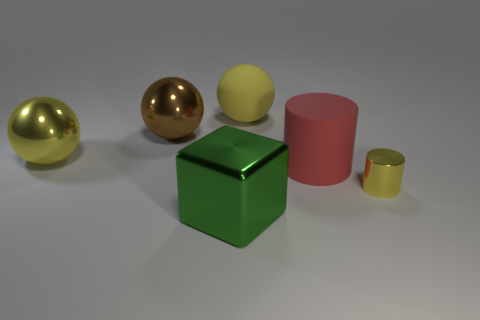Subtract all big yellow metallic spheres. How many spheres are left? 2 Add 2 brown balls. How many objects exist? 8 Subtract all red cylinders. How many yellow spheres are left? 2 Subtract all yellow cylinders. How many cylinders are left? 1 Subtract all cylinders. How many objects are left? 4 Add 4 large brown balls. How many large brown balls are left? 5 Add 2 shiny things. How many shiny things exist? 6 Subtract 0 purple cylinders. How many objects are left? 6 Subtract all blue cubes. Subtract all green spheres. How many cubes are left? 1 Subtract all small cylinders. Subtract all tiny cylinders. How many objects are left? 4 